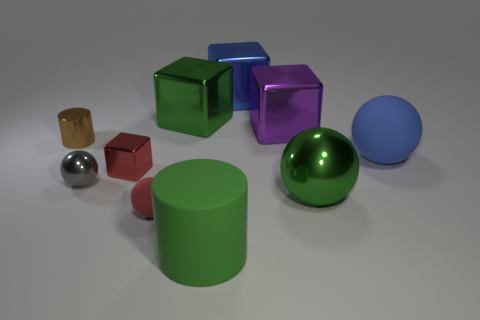What number of objects are cubes that are on the right side of the blue metal object or large blue things that are on the right side of the big purple object?
Provide a succinct answer. 2. What number of other things are there of the same size as the green shiny ball?
Give a very brief answer. 5. Is the color of the matte ball that is to the right of the big green matte object the same as the big matte cylinder?
Your answer should be compact. No. There is a ball that is to the left of the large purple metallic object and in front of the small gray metal sphere; how big is it?
Give a very brief answer. Small. How many small things are either blocks or blue metallic things?
Provide a succinct answer. 1. There is a large matte object right of the big purple thing; what shape is it?
Offer a very short reply. Sphere. How many small spheres are there?
Provide a succinct answer. 2. Do the big green ball and the small brown cylinder have the same material?
Keep it short and to the point. Yes. Is the number of purple metallic cubes that are behind the blue metal object greater than the number of large rubber spheres?
Provide a succinct answer. No. What number of objects are either green metal balls or things to the left of the red shiny object?
Provide a short and direct response. 3. 